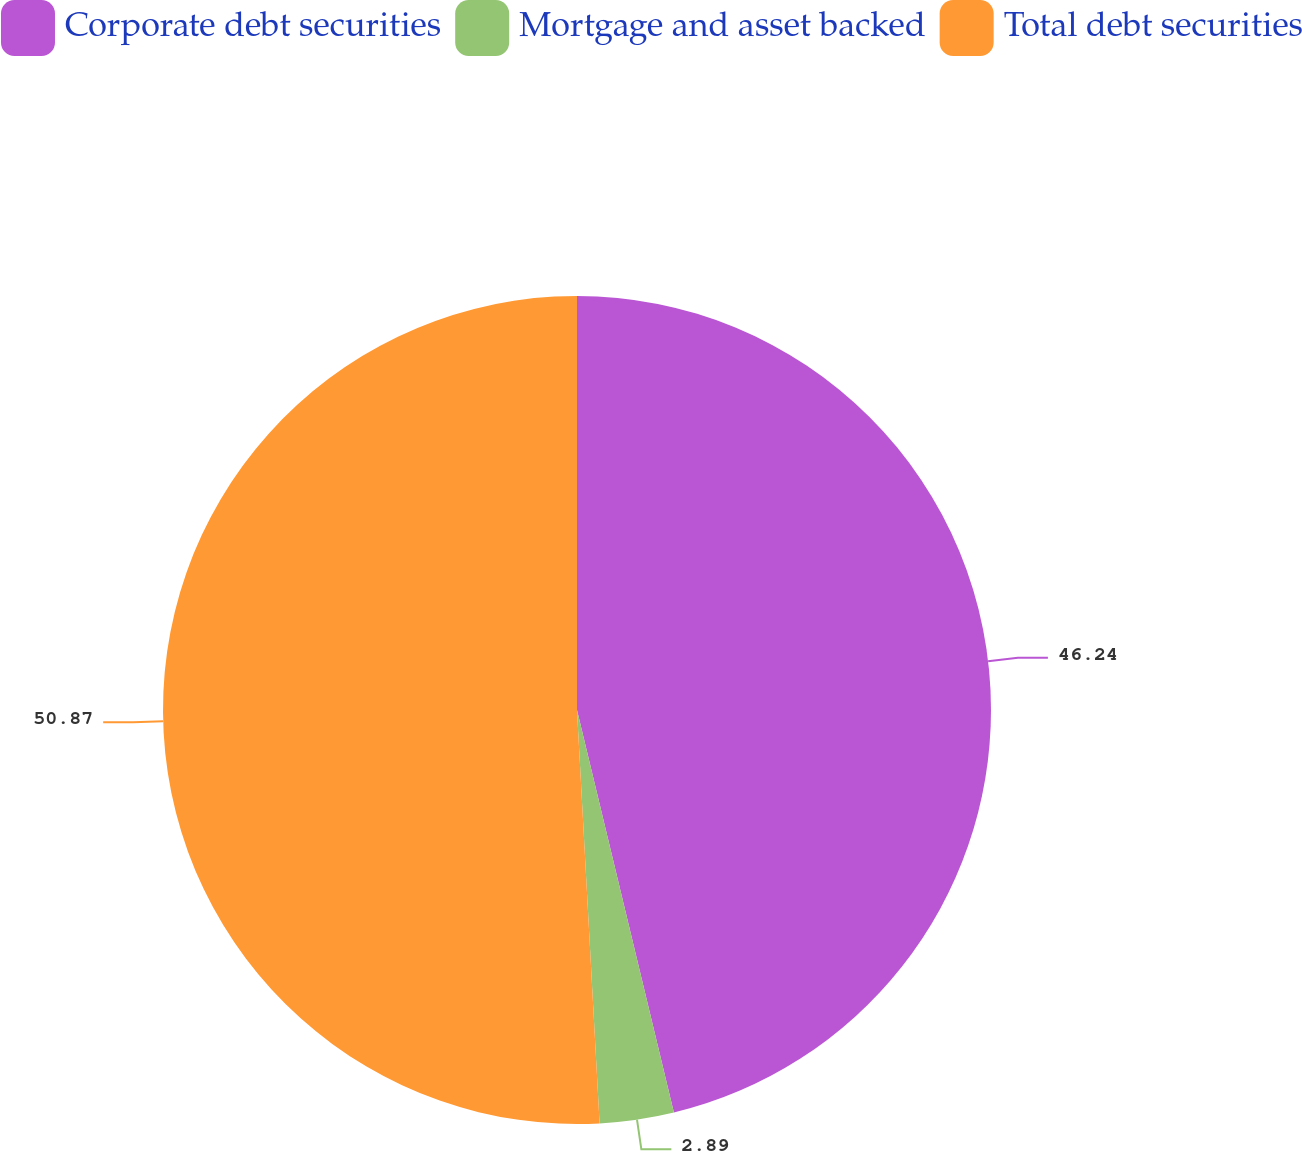<chart> <loc_0><loc_0><loc_500><loc_500><pie_chart><fcel>Corporate debt securities<fcel>Mortgage and asset backed<fcel>Total debt securities<nl><fcel>46.24%<fcel>2.89%<fcel>50.87%<nl></chart> 